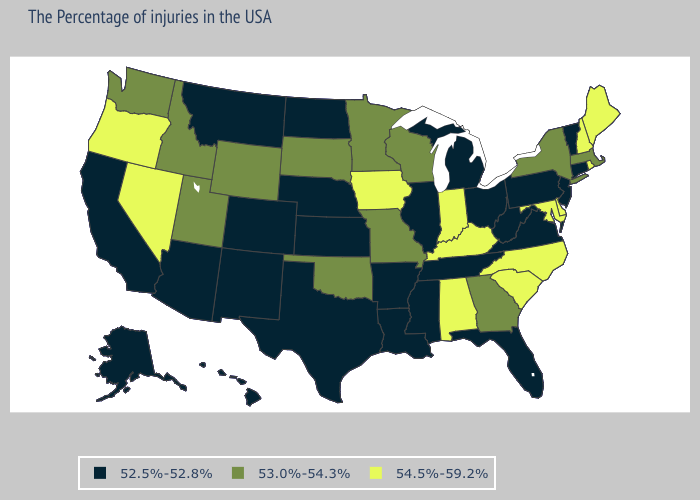Name the states that have a value in the range 54.5%-59.2%?
Short answer required. Maine, Rhode Island, New Hampshire, Delaware, Maryland, North Carolina, South Carolina, Kentucky, Indiana, Alabama, Iowa, Nevada, Oregon. Does Connecticut have the lowest value in the Northeast?
Short answer required. Yes. Name the states that have a value in the range 54.5%-59.2%?
Quick response, please. Maine, Rhode Island, New Hampshire, Delaware, Maryland, North Carolina, South Carolina, Kentucky, Indiana, Alabama, Iowa, Nevada, Oregon. Among the states that border Nebraska , which have the lowest value?
Be succinct. Kansas, Colorado. What is the lowest value in states that border Maryland?
Answer briefly. 52.5%-52.8%. What is the value of Virginia?
Give a very brief answer. 52.5%-52.8%. Name the states that have a value in the range 52.5%-52.8%?
Write a very short answer. Vermont, Connecticut, New Jersey, Pennsylvania, Virginia, West Virginia, Ohio, Florida, Michigan, Tennessee, Illinois, Mississippi, Louisiana, Arkansas, Kansas, Nebraska, Texas, North Dakota, Colorado, New Mexico, Montana, Arizona, California, Alaska, Hawaii. Is the legend a continuous bar?
Answer briefly. No. Among the states that border Wyoming , which have the lowest value?
Keep it brief. Nebraska, Colorado, Montana. What is the lowest value in states that border Michigan?
Give a very brief answer. 52.5%-52.8%. Name the states that have a value in the range 53.0%-54.3%?
Keep it brief. Massachusetts, New York, Georgia, Wisconsin, Missouri, Minnesota, Oklahoma, South Dakota, Wyoming, Utah, Idaho, Washington. Does the map have missing data?
Keep it brief. No. Name the states that have a value in the range 54.5%-59.2%?
Give a very brief answer. Maine, Rhode Island, New Hampshire, Delaware, Maryland, North Carolina, South Carolina, Kentucky, Indiana, Alabama, Iowa, Nevada, Oregon. What is the value of Idaho?
Concise answer only. 53.0%-54.3%. Name the states that have a value in the range 53.0%-54.3%?
Short answer required. Massachusetts, New York, Georgia, Wisconsin, Missouri, Minnesota, Oklahoma, South Dakota, Wyoming, Utah, Idaho, Washington. 